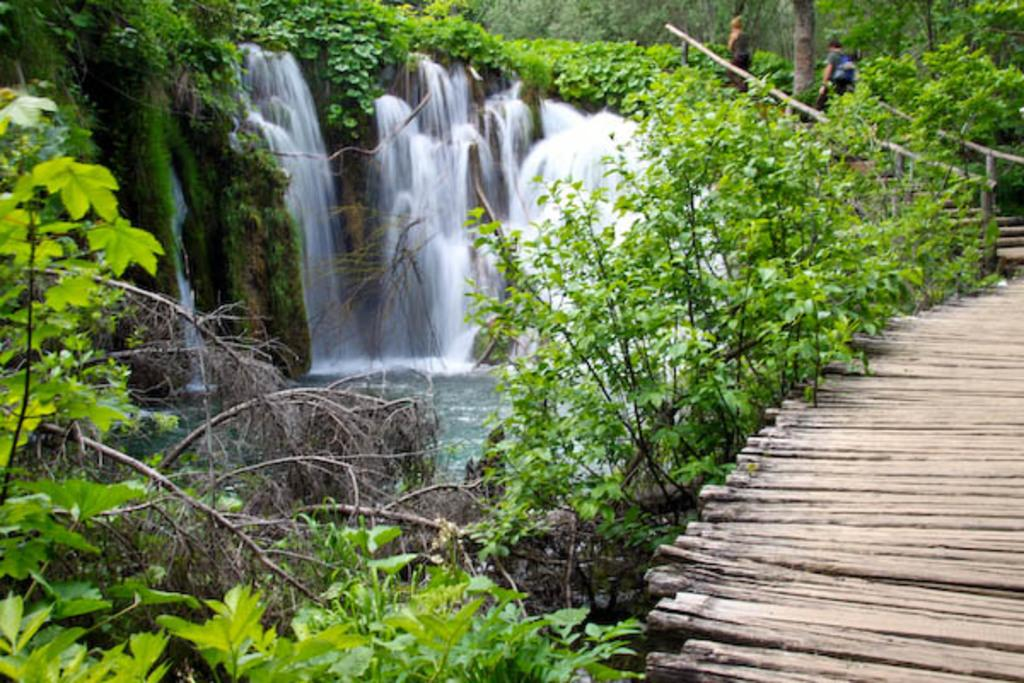What type of scene is shown in the image? The image depicts a beautiful view of nature. Can you describe any structures in the image? There is a wooden bridge in the bottom front side of the image. What else can be seen near the wooden bridge? There are plants near the wooden bridge. What natural feature is visible in the image? There is a waterfall visible in the image. What is located behind the waterfall? Trees are present behind the waterfall. Where is the nearest shop to the waterfall in the image? There is no shop present in the image, as it depicts a natural scene with a waterfall and trees. 